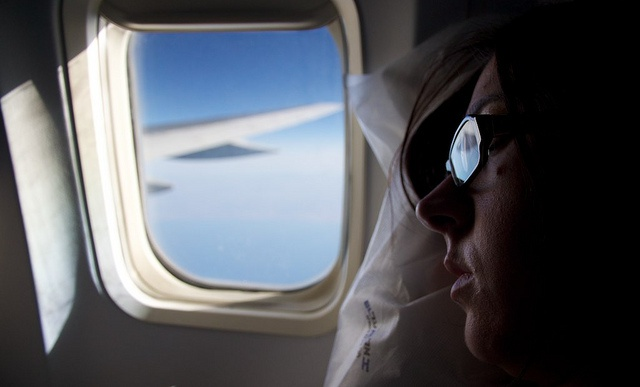Describe the objects in this image and their specific colors. I can see people in black, gray, and darkgray tones in this image. 